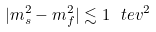<formula> <loc_0><loc_0><loc_500><loc_500>| m _ { s } ^ { 2 } - m _ { f } ^ { 2 } | \lesssim 1 \ t e v ^ { 2 }</formula> 